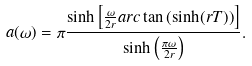Convert formula to latex. <formula><loc_0><loc_0><loc_500><loc_500>a ( \omega ) = \pi \frac { \sinh \left [ \frac { \omega } { 2 r } a r c \tan \left ( \sinh ( r T ) \right ) \right ] } { \sinh \left ( \frac { \pi \omega } { 2 r } \right ) } .</formula> 